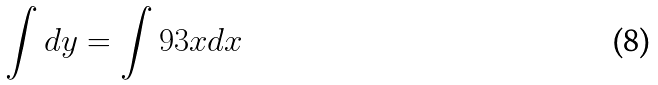Convert formula to latex. <formula><loc_0><loc_0><loc_500><loc_500>\int d y = \int 9 3 x d x</formula> 